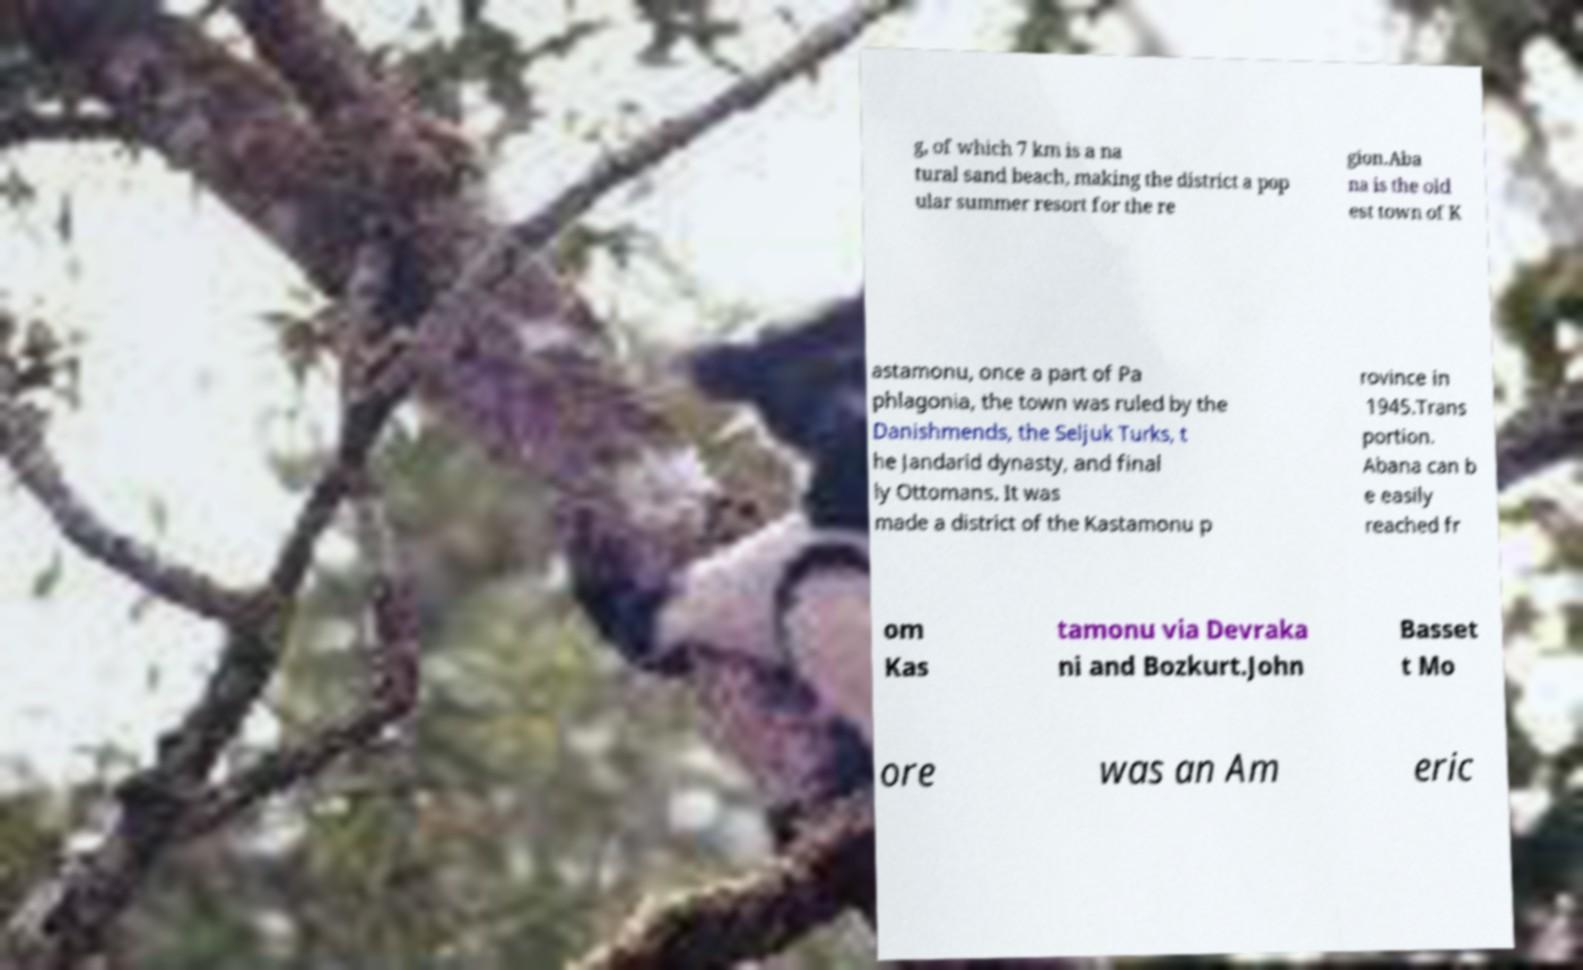Can you read and provide the text displayed in the image?This photo seems to have some interesting text. Can you extract and type it out for me? g, of which 7 km is a na tural sand beach, making the district a pop ular summer resort for the re gion.Aba na is the old est town of K astamonu, once a part of Pa phlagonia, the town was ruled by the Danishmends, the Seljuk Turks, t he Jandarid dynasty, and final ly Ottomans. It was made a district of the Kastamonu p rovince in 1945.Trans portion. Abana can b e easily reached fr om Kas tamonu via Devraka ni and Bozkurt.John Basset t Mo ore was an Am eric 